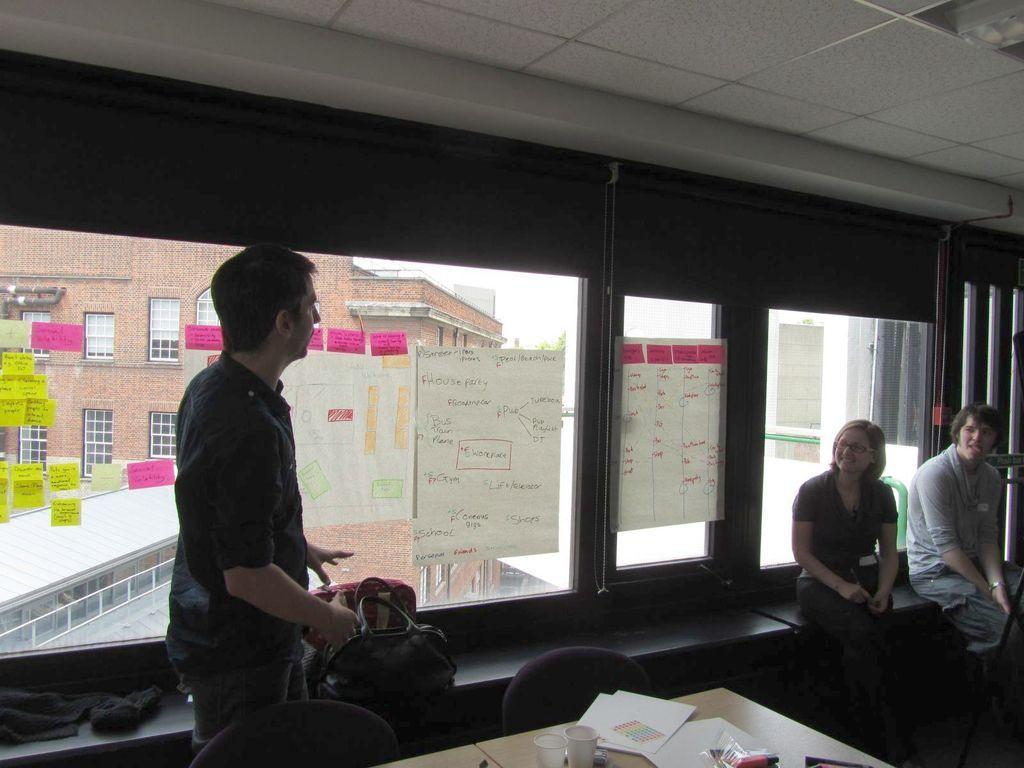Can you describe this image briefly? At the top we can see the ceiling. Through the glass outside view is visible and we can see a building, windows, railing, tree and a roof. In this picture we can see the people sitting on the platform and we can see the bags and a cloth on the platform. On the left side of the picture we can see a man is standing. On the glass we can see few sticky notes and paper notes. At the bottom portion of the picture we can see the chairs. On a table we can see the papers, glasses and few objects. 